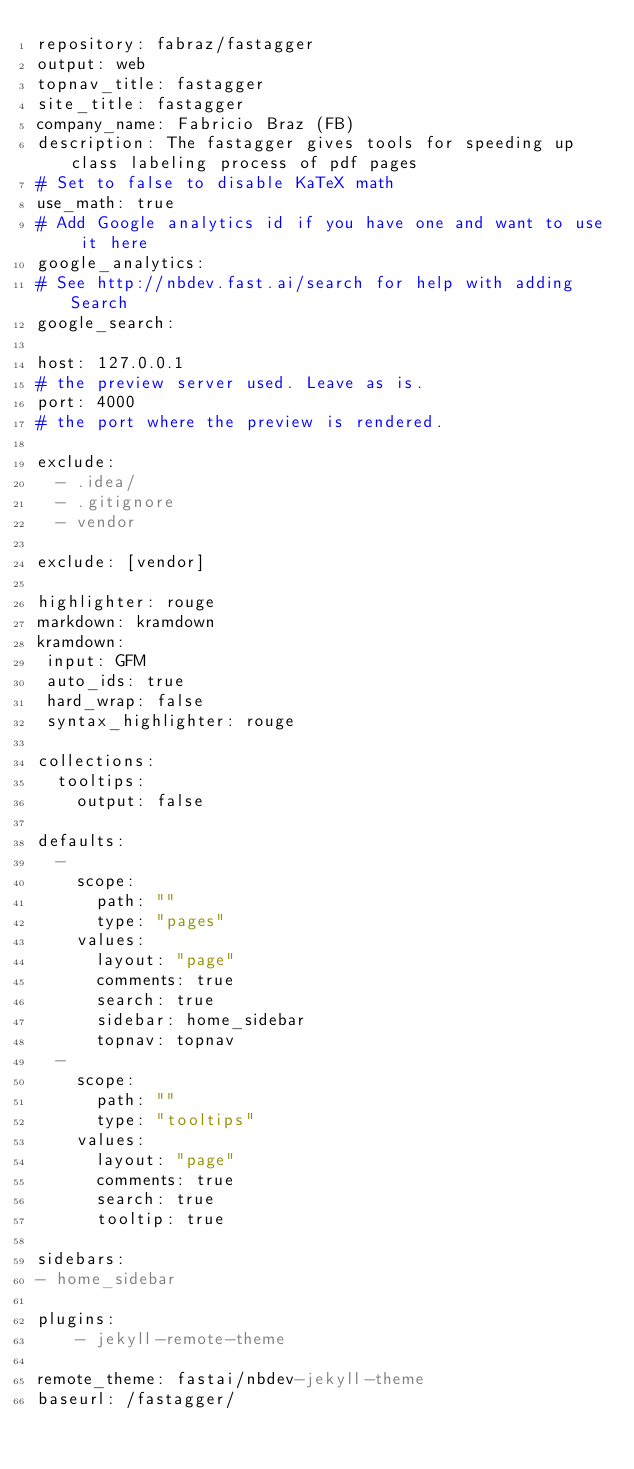<code> <loc_0><loc_0><loc_500><loc_500><_YAML_>repository: fabraz/fastagger
output: web
topnav_title: fastagger
site_title: fastagger
company_name: Fabricio Braz (FB)
description: The fastagger gives tools for speeding up class labeling process of pdf pages
# Set to false to disable KaTeX math
use_math: true
# Add Google analytics id if you have one and want to use it here
google_analytics:
# See http://nbdev.fast.ai/search for help with adding Search
google_search:

host: 127.0.0.1
# the preview server used. Leave as is.
port: 4000
# the port where the preview is rendered.

exclude:
  - .idea/
  - .gitignore
  - vendor
 
exclude: [vendor]

highlighter: rouge
markdown: kramdown
kramdown:
 input: GFM
 auto_ids: true
 hard_wrap: false
 syntax_highlighter: rouge

collections:
  tooltips:
    output: false

defaults:
  -
    scope:
      path: ""
      type: "pages"
    values:
      layout: "page"
      comments: true
      search: true
      sidebar: home_sidebar
      topnav: topnav
  -
    scope:
      path: ""
      type: "tooltips"
    values:
      layout: "page"
      comments: true
      search: true
      tooltip: true

sidebars:
- home_sidebar

plugins:
    - jekyll-remote-theme
    
remote_theme: fastai/nbdev-jekyll-theme
baseurl: /fastagger/</code> 